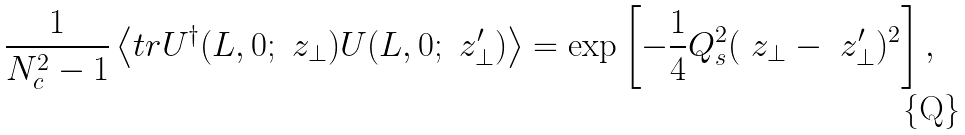Convert formula to latex. <formula><loc_0><loc_0><loc_500><loc_500>\frac { 1 } { N _ { c } ^ { 2 } - 1 } \left < { t r } U ^ { \dagger } ( L , 0 ; \ z _ { \perp } ) U ( L , 0 ; \ z ^ { \prime } _ { \perp } ) \right > = \exp \left [ - \frac { 1 } { 4 } Q _ { s } ^ { 2 } ( \ z _ { \perp } - \ z ^ { \prime } _ { \perp } ) ^ { 2 } \right ] ,</formula> 